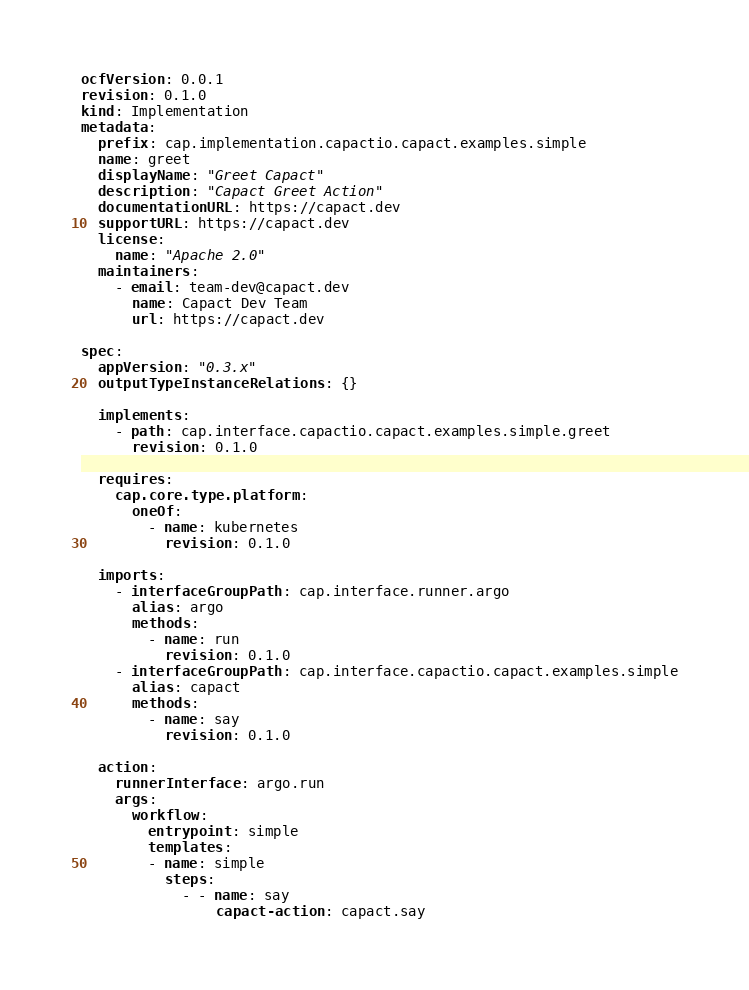<code> <loc_0><loc_0><loc_500><loc_500><_YAML_>ocfVersion: 0.0.1
revision: 0.1.0
kind: Implementation
metadata:
  prefix: cap.implementation.capactio.capact.examples.simple
  name: greet
  displayName: "Greet Capact"
  description: "Capact Greet Action"
  documentationURL: https://capact.dev
  supportURL: https://capact.dev
  license:
    name: "Apache 2.0"
  maintainers:
    - email: team-dev@capact.dev
      name: Capact Dev Team
      url: https://capact.dev

spec:
  appVersion: "0.3.x"
  outputTypeInstanceRelations: {}

  implements:
    - path: cap.interface.capactio.capact.examples.simple.greet
      revision: 0.1.0

  requires:
    cap.core.type.platform:
      oneOf:
        - name: kubernetes
          revision: 0.1.0

  imports:
    - interfaceGroupPath: cap.interface.runner.argo
      alias: argo
      methods:
        - name: run
          revision: 0.1.0
    - interfaceGroupPath: cap.interface.capactio.capact.examples.simple
      alias: capact
      methods:
        - name: say
          revision: 0.1.0

  action:
    runnerInterface: argo.run
    args:
      workflow:
        entrypoint: simple
        templates:
        - name: simple
          steps:
            - - name: say
                capact-action: capact.say
</code> 